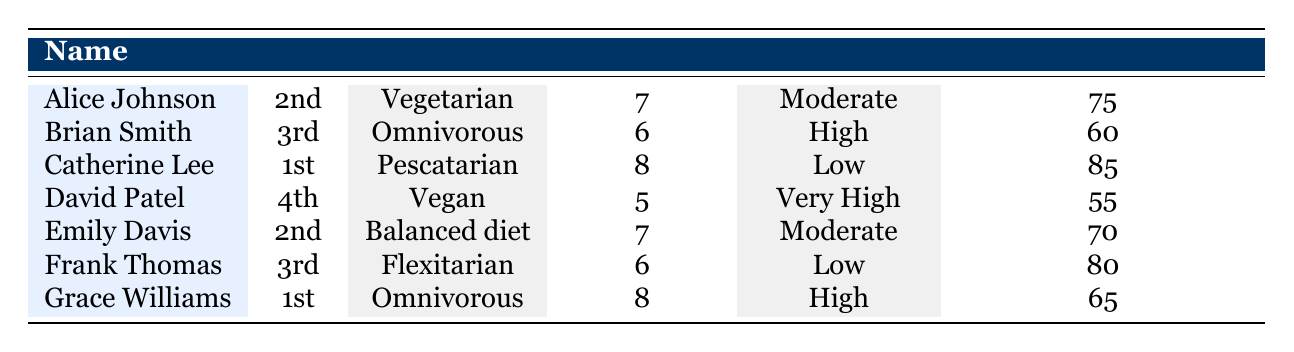What's the diet type of Alice Johnson? From the table, we can directly find Alice Johnson's row, where the diet type is explicitly stated as "Vegetarian."
Answer: Vegetarian How many servings of fruits does Brian Smith consume daily? Looking at the row for Brian Smith, the table indicates that his fruit intake is "1 serving/day."
Answer: 1 serving/day What is the average mental health score of all students? To calculate the average, sum the mental health scores of all students: 75 + 60 + 85 + 55 + 70 + 80 + 65 = 490. There are 7 students, so the average is 490 / 7 = 70.
Answer: 70 Is Emily Davis' sleep hours higher than David Patel's? Checking the sleep hours for Emily Davis, which is 7, and David Patel, which is 5, we can see that 7 is greater than 5.
Answer: Yes What is the difference in mental health scores between the highest (Catherine Lee) and the lowest (David Patel)? Catherine Lee's mental health score is 85, and David Patel's is 55. The difference is calculated by subtracting: 85 - 55 = 30.
Answer: 30 Which student consumes the most servings of vegetables daily? By reviewing the vegetable intake, David Patel consumes 2 servings/day, while Brian Smith consumes 5 servings/day. Therefore, Brian Smith consumes the most vegetables daily.
Answer: Brian Smith How many students have a stress level categorized as "Low"? From the table, we identify which students have a stress level of "Low": Catherine Lee and Frank Thomas. This gives us a total of 2 students.
Answer: 2 What combination of factors correlates with a high mental health score? Analyzing the data, students with high mental health scores like Catherine Lee and Frank Thomas tend to have a diet with higher fruit and vegetable intake, consistent water intake, adequate sleep hours, and lower stress levels.
Answer: High intake of fruits and vegetables, water, adequate sleep, and low stress levels How many servings of vegetables does Grace Williams consume compared to Catherine Lee? Grace Williams consumes 1 serving/day, whereas Catherine Lee consumes 4 servings/day. Therefore, Catherine Lee consumes 3 more servings of vegetables than Grace Williams.
Answer: Catherine Lee consumes 3 more servings 